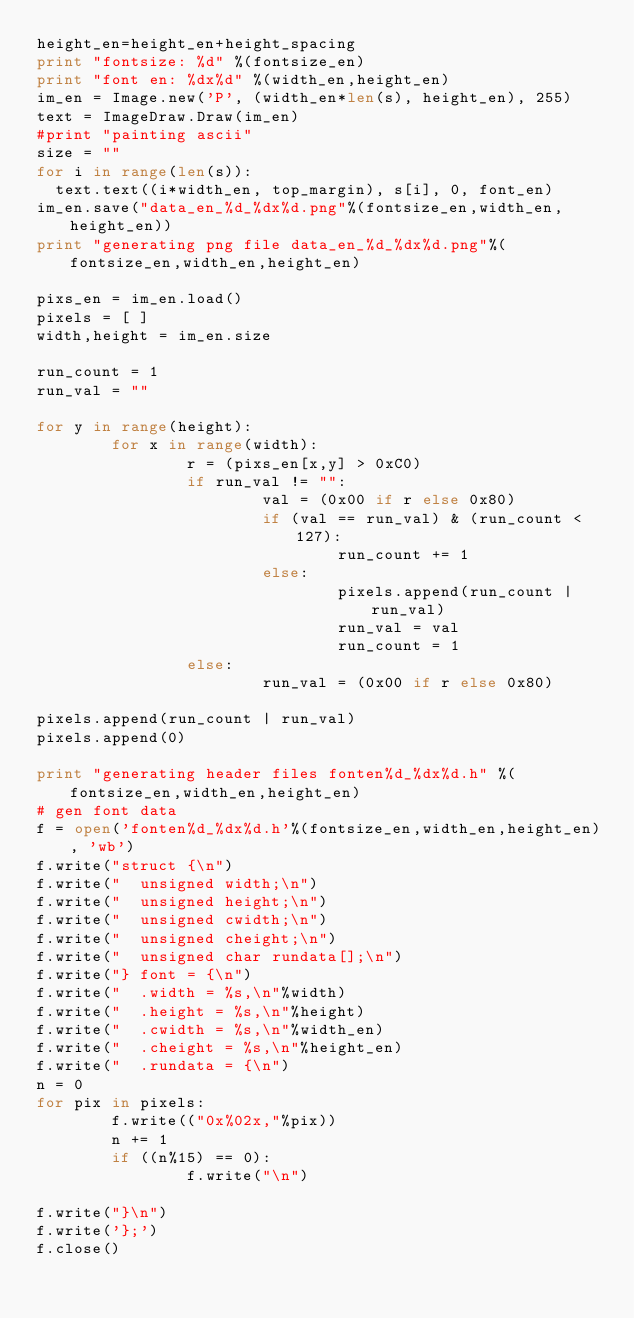<code> <loc_0><loc_0><loc_500><loc_500><_Python_>height_en=height_en+height_spacing
print "fontsize: %d" %(fontsize_en)
print "font en: %dx%d" %(width_en,height_en)
im_en = Image.new('P', (width_en*len(s), height_en), 255)
text = ImageDraw.Draw(im_en)
#print "painting ascii"
size = ""
for i in range(len(s)):
	text.text((i*width_en, top_margin), s[i], 0, font_en)
im_en.save("data_en_%d_%dx%d.png"%(fontsize_en,width_en,height_en))
print "generating png file data_en_%d_%dx%d.png"%(fontsize_en,width_en,height_en)

pixs_en = im_en.load()
pixels = [ ]
width,height = im_en.size

run_count = 1
run_val = ""

for y in range(height):
        for x in range(width):
                r = (pixs_en[x,y] > 0xC0)
                if run_val != "":
                        val = (0x00 if r else 0x80)
                        if (val == run_val) & (run_count < 127):
                                run_count += 1
                        else:
                                pixels.append(run_count | run_val)
                                run_val = val
                                run_count = 1
                else:
                        run_val = (0x00 if r else 0x80)

pixels.append(run_count | run_val)
pixels.append(0)

print "generating header files fonten%d_%dx%d.h" %(fontsize_en,width_en,height_en)
# gen font data
f = open('fonten%d_%dx%d.h'%(fontsize_en,width_en,height_en), 'wb')
f.write("struct {\n")
f.write("  unsigned width;\n")
f.write("  unsigned height;\n")
f.write("  unsigned cwidth;\n")
f.write("  unsigned cheight;\n")
f.write("  unsigned char rundata[];\n")
f.write("} font = {\n")
f.write("  .width = %s,\n"%width)
f.write("  .height = %s,\n"%height)
f.write("  .cwidth = %s,\n"%width_en)
f.write("  .cheight = %s,\n"%height_en)
f.write("  .rundata = {\n")
n = 0
for pix in pixels:
        f.write(("0x%02x,"%pix))
        n += 1
        if ((n%15) == 0):
                f.write("\n")

f.write("}\n")
f.write('};')
f.close()

</code> 